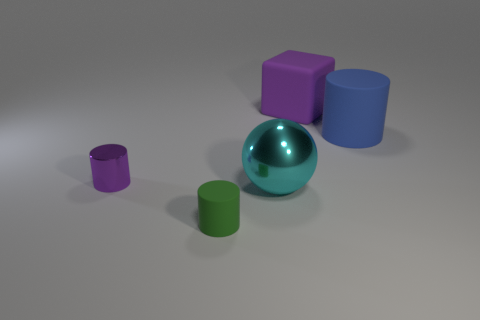Subtract all red balls. Subtract all yellow cylinders. How many balls are left? 1 Add 4 small metallic things. How many objects exist? 9 Subtract all cylinders. How many objects are left? 2 Add 1 rubber cubes. How many rubber cubes are left? 2 Add 1 big cyan metal spheres. How many big cyan metal spheres exist? 2 Subtract 1 green cylinders. How many objects are left? 4 Subtract all blue matte things. Subtract all green rubber objects. How many objects are left? 3 